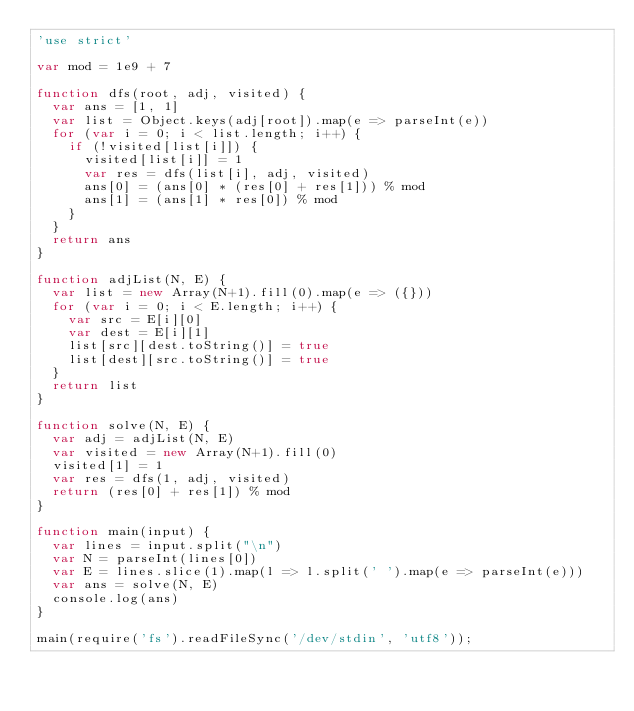<code> <loc_0><loc_0><loc_500><loc_500><_JavaScript_>'use strict'

var mod = 1e9 + 7

function dfs(root, adj, visited) {
  var ans = [1, 1]
  var list = Object.keys(adj[root]).map(e => parseInt(e))
  for (var i = 0; i < list.length; i++) {
    if (!visited[list[i]]) {
      visited[list[i]] = 1
      var res = dfs(list[i], adj, visited)
      ans[0] = (ans[0] * (res[0] + res[1])) % mod
      ans[1] = (ans[1] * res[0]) % mod
    }
  }
  return ans
}

function adjList(N, E) {
  var list = new Array(N+1).fill(0).map(e => ({}))
  for (var i = 0; i < E.length; i++) {
    var src = E[i][0]
    var dest = E[i][1]
    list[src][dest.toString()] = true
    list[dest][src.toString()] = true
  }
  return list
}

function solve(N, E) {
  var adj = adjList(N, E)
  var visited = new Array(N+1).fill(0)
  visited[1] = 1
  var res = dfs(1, adj, visited)
  return (res[0] + res[1]) % mod
}

function main(input) {
  var lines = input.split("\n")
  var N = parseInt(lines[0])
  var E = lines.slice(1).map(l => l.split(' ').map(e => parseInt(e)))
  var ans = solve(N, E)
  console.log(ans)
}

main(require('fs').readFileSync('/dev/stdin', 'utf8'));
</code> 